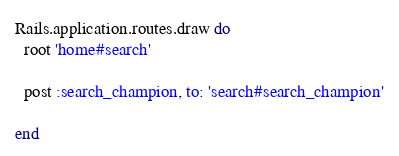Convert code to text. <code><loc_0><loc_0><loc_500><loc_500><_Ruby_>Rails.application.routes.draw do
  root 'home#search'

  post :search_champion, to: 'search#search_champion'

end
</code> 